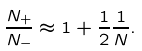Convert formula to latex. <formula><loc_0><loc_0><loc_500><loc_500>\frac { N _ { + } } { N _ { - } } \approx 1 + \frac { 1 } { 2 } \frac { 1 } { N } .</formula> 